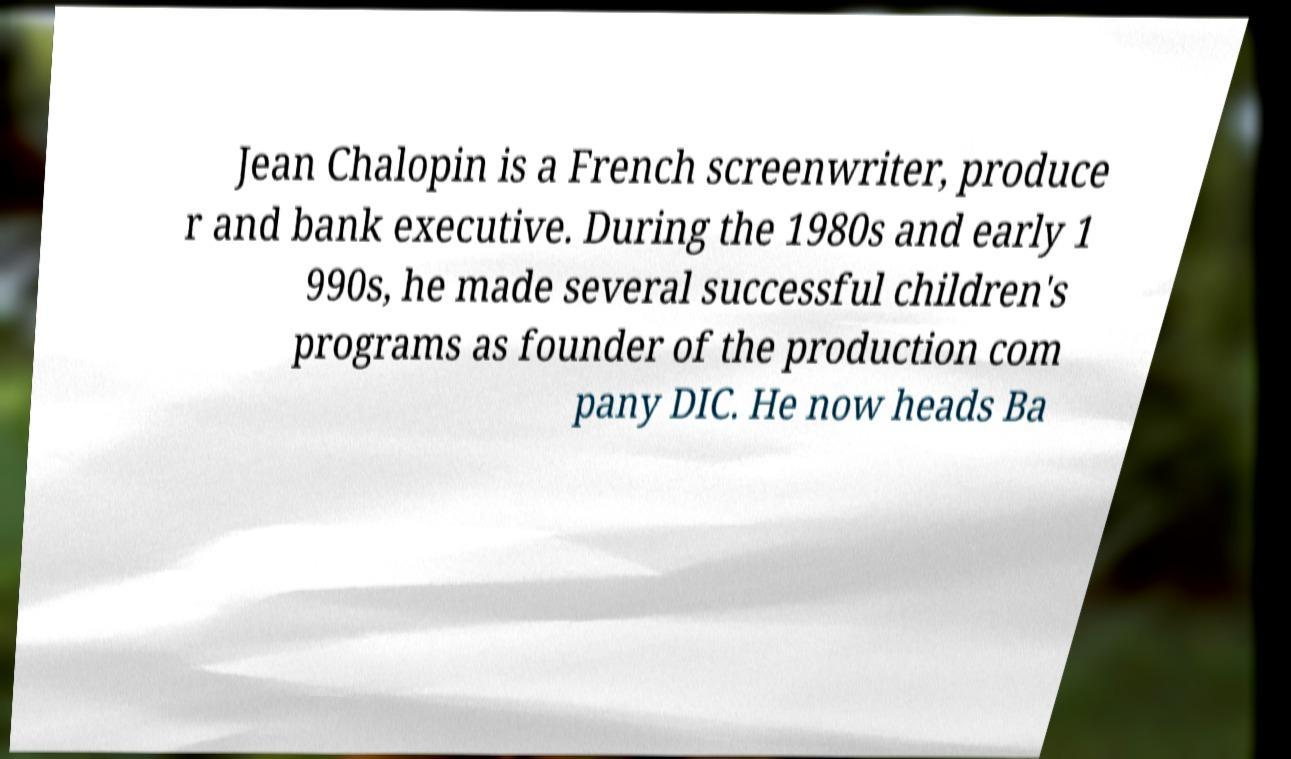Can you read and provide the text displayed in the image?This photo seems to have some interesting text. Can you extract and type it out for me? Jean Chalopin is a French screenwriter, produce r and bank executive. During the 1980s and early 1 990s, he made several successful children's programs as founder of the production com pany DIC. He now heads Ba 